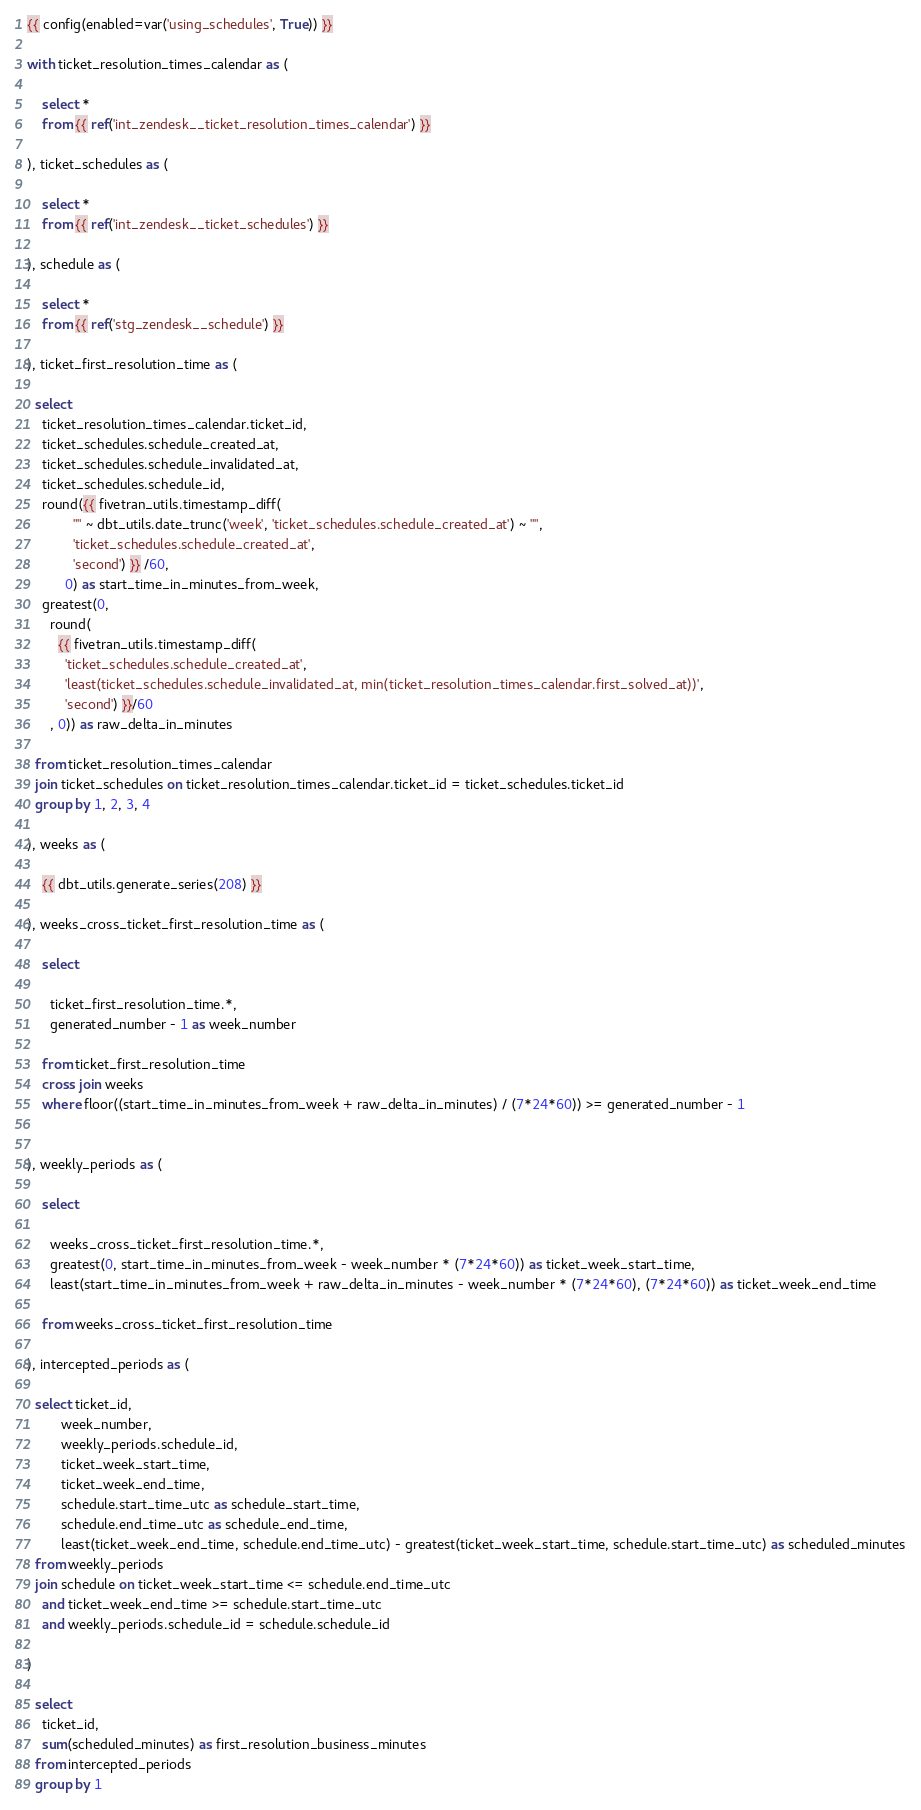<code> <loc_0><loc_0><loc_500><loc_500><_SQL_>{{ config(enabled=var('using_schedules', True)) }}

with ticket_resolution_times_calendar as (

    select *
    from {{ ref('int_zendesk__ticket_resolution_times_calendar') }}

), ticket_schedules as (

    select *
    from {{ ref('int_zendesk__ticket_schedules') }}

), schedule as (

    select *
    from {{ ref('stg_zendesk__schedule') }}

), ticket_first_resolution_time as (

  select 
    ticket_resolution_times_calendar.ticket_id,
    ticket_schedules.schedule_created_at,
    ticket_schedules.schedule_invalidated_at,
    ticket_schedules.schedule_id,
    round({{ fivetran_utils.timestamp_diff(
            "" ~ dbt_utils.date_trunc('week', 'ticket_schedules.schedule_created_at') ~ "", 
            'ticket_schedules.schedule_created_at',
            'second') }} /60,
          0) as start_time_in_minutes_from_week,
    greatest(0,
      round(
        {{ fivetran_utils.timestamp_diff(
          'ticket_schedules.schedule_created_at',
          'least(ticket_schedules.schedule_invalidated_at, min(ticket_resolution_times_calendar.first_solved_at))',
          'second') }}/60
      , 0)) as raw_delta_in_minutes
      
  from ticket_resolution_times_calendar
  join ticket_schedules on ticket_resolution_times_calendar.ticket_id = ticket_schedules.ticket_id
  group by 1, 2, 3, 4

), weeks as (

    {{ dbt_utils.generate_series(208) }}

), weeks_cross_ticket_first_resolution_time as (

    select 

      ticket_first_resolution_time.*,
      generated_number - 1 as week_number

    from ticket_first_resolution_time
    cross join weeks
    where floor((start_time_in_minutes_from_week + raw_delta_in_minutes) / (7*24*60)) >= generated_number - 1


), weekly_periods as (
  
    select 

      weeks_cross_ticket_first_resolution_time.*,
      greatest(0, start_time_in_minutes_from_week - week_number * (7*24*60)) as ticket_week_start_time,
      least(start_time_in_minutes_from_week + raw_delta_in_minutes - week_number * (7*24*60), (7*24*60)) as ticket_week_end_time
    
    from weeks_cross_ticket_first_resolution_time

), intercepted_periods as (

  select ticket_id,
         week_number,
         weekly_periods.schedule_id,
         ticket_week_start_time,
         ticket_week_end_time,
         schedule.start_time_utc as schedule_start_time,
         schedule.end_time_utc as schedule_end_time,
         least(ticket_week_end_time, schedule.end_time_utc) - greatest(ticket_week_start_time, schedule.start_time_utc) as scheduled_minutes
  from weekly_periods
  join schedule on ticket_week_start_time <= schedule.end_time_utc 
    and ticket_week_end_time >= schedule.start_time_utc
    and weekly_periods.schedule_id = schedule.schedule_id

)

  select 
    ticket_id,
    sum(scheduled_minutes) as first_resolution_business_minutes
  from intercepted_periods
  group by 1</code> 